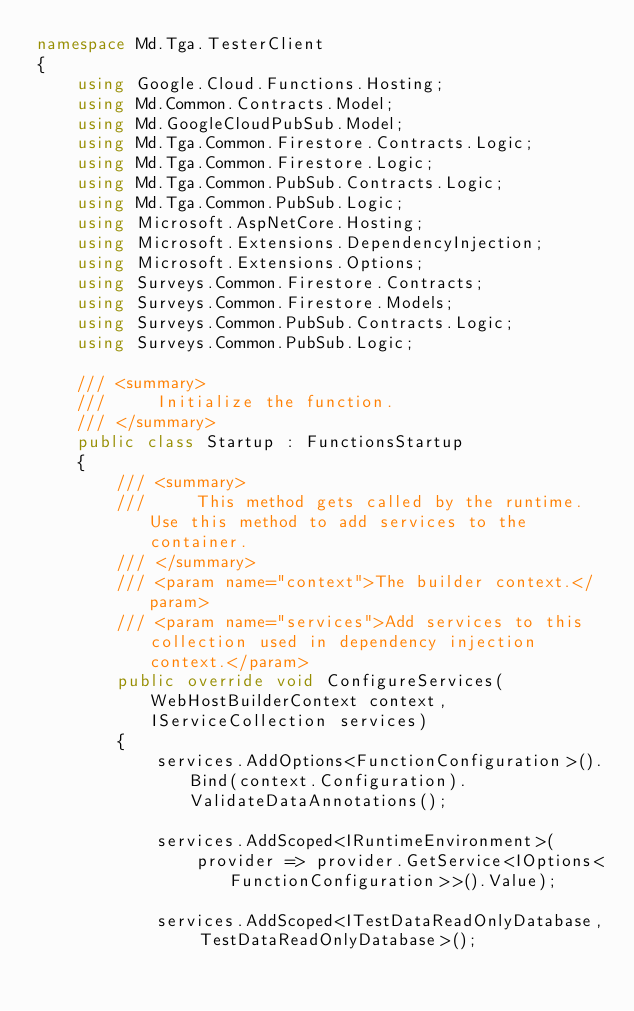<code> <loc_0><loc_0><loc_500><loc_500><_C#_>namespace Md.Tga.TesterClient
{
    using Google.Cloud.Functions.Hosting;
    using Md.Common.Contracts.Model;
    using Md.GoogleCloudPubSub.Model;
    using Md.Tga.Common.Firestore.Contracts.Logic;
    using Md.Tga.Common.Firestore.Logic;
    using Md.Tga.Common.PubSub.Contracts.Logic;
    using Md.Tga.Common.PubSub.Logic;
    using Microsoft.AspNetCore.Hosting;
    using Microsoft.Extensions.DependencyInjection;
    using Microsoft.Extensions.Options;
    using Surveys.Common.Firestore.Contracts;
    using Surveys.Common.Firestore.Models;
    using Surveys.Common.PubSub.Contracts.Logic;
    using Surveys.Common.PubSub.Logic;

    /// <summary>
    ///     Initialize the function.
    /// </summary>
    public class Startup : FunctionsStartup
    {
        /// <summary>
        ///     This method gets called by the runtime. Use this method to add services to the container.
        /// </summary>
        /// <param name="context">The builder context.</param>
        /// <param name="services">Add services to this collection used in dependency injection context.</param>
        public override void ConfigureServices(WebHostBuilderContext context, IServiceCollection services)
        {
            services.AddOptions<FunctionConfiguration>().Bind(context.Configuration).ValidateDataAnnotations();

            services.AddScoped<IRuntimeEnvironment>(
                provider => provider.GetService<IOptions<FunctionConfiguration>>().Value);

            services.AddScoped<ITestDataReadOnlyDatabase, TestDataReadOnlyDatabase>();</code> 